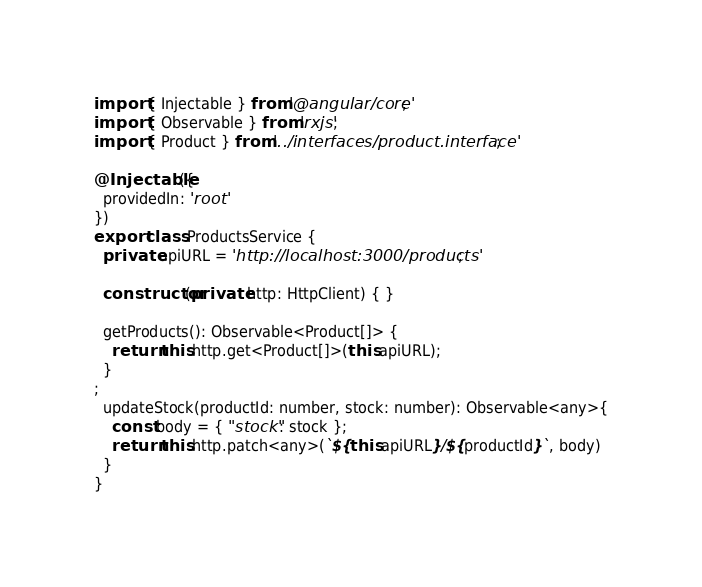<code> <loc_0><loc_0><loc_500><loc_500><_TypeScript_>import { Injectable } from '@angular/core';
import { Observable } from 'rxjs';
import { Product } from '../interfaces/product.interface';

@Injectable({
  providedIn: 'root'
})
export class ProductsService {
  private apiURL = 'http://localhost:3000/products';

  constructor(private http: HttpClient) { }

  getProducts(): Observable<Product[]> {
    return this.http.get<Product[]>(this.apiURL);
  }
;
  updateStock(productId: number, stock: number): Observable<any>{
    const body = { "stock": stock };
    return this.http.patch<any>(`${this.apiURL}/${productId}`, body)
  }
}
</code> 